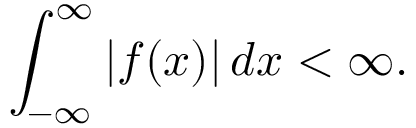<formula> <loc_0><loc_0><loc_500><loc_500>\int _ { - \infty } ^ { \infty } | f ( x ) | \, d x < \infty .</formula> 